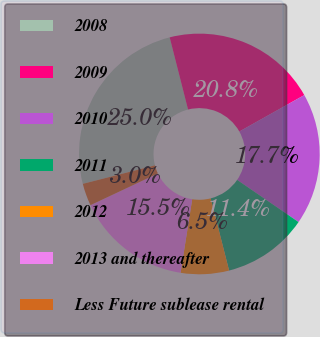<chart> <loc_0><loc_0><loc_500><loc_500><pie_chart><fcel>2008<fcel>2009<fcel>2010<fcel>2011<fcel>2012<fcel>2013 and thereafter<fcel>Less Future sublease rental<nl><fcel>25.03%<fcel>20.83%<fcel>17.71%<fcel>11.45%<fcel>6.47%<fcel>15.51%<fcel>3.0%<nl></chart> 